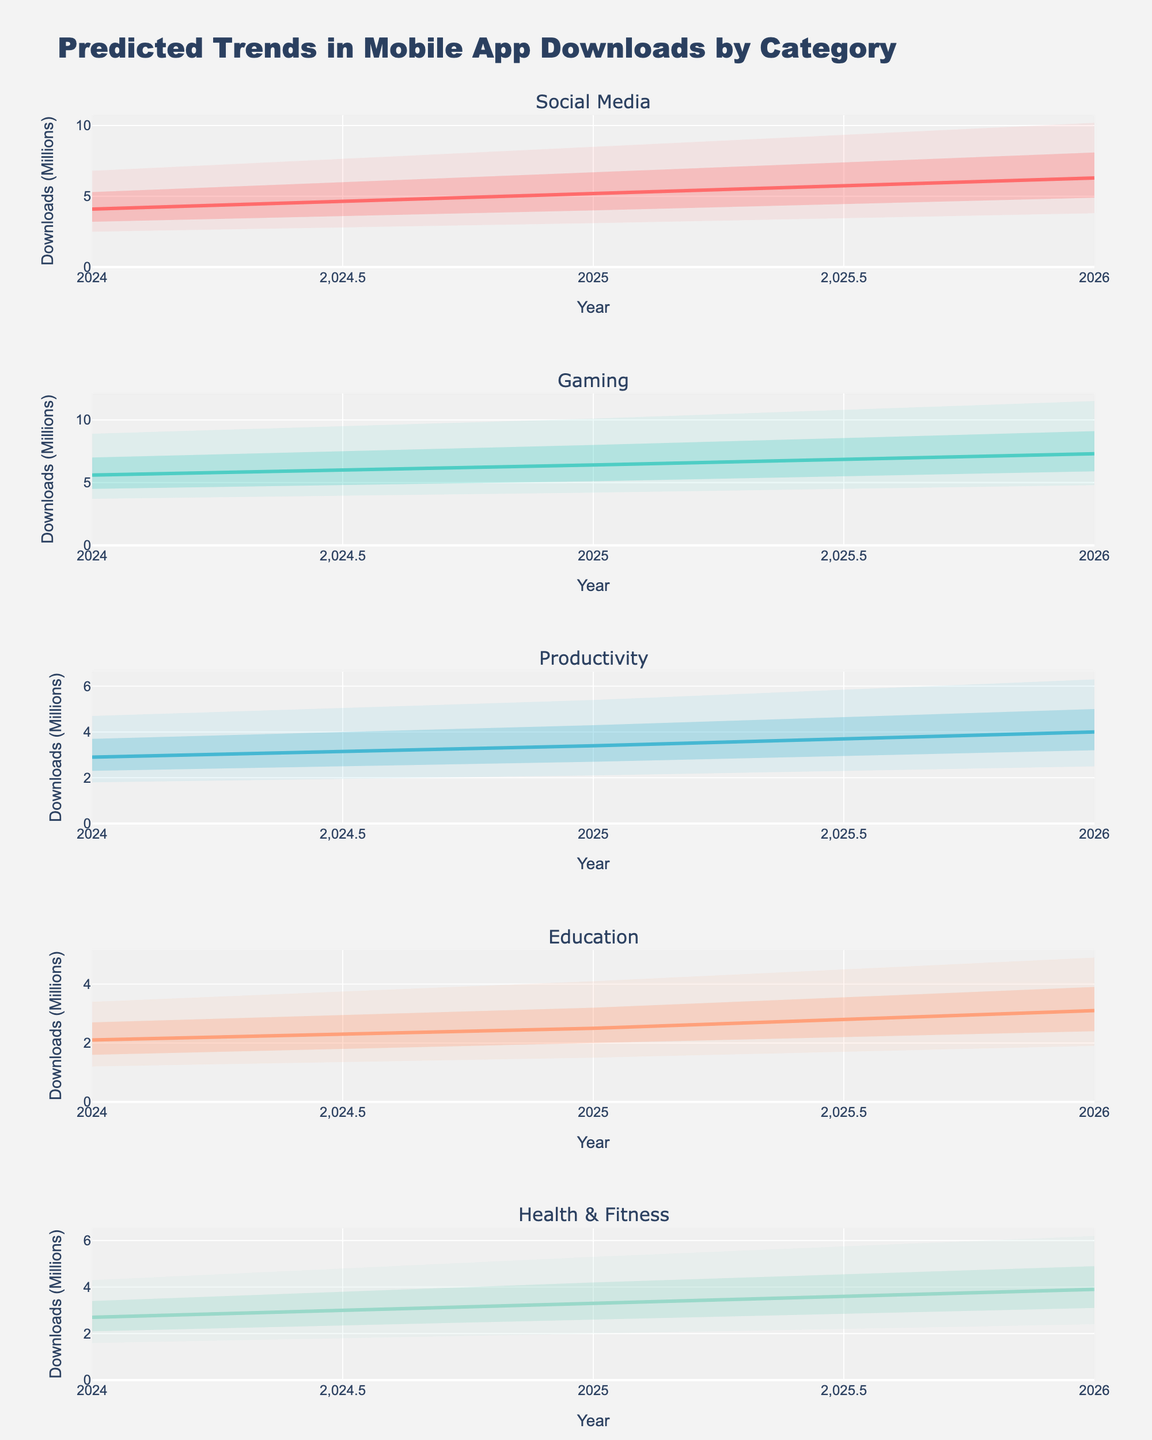What is the title of the figure? The title is located at the top of the figure and provides a summary of what the figure represents.
Answer: Predicted Trends in Mobile App Downloads by Category How many categories are represented in the figure? Each subplot title indicates a different category, and there are multiple subplots stacked vertically.
Answer: 5 What is the predicted median (P50) value for Social Media app downloads in 2025? Locate the Social Media category section, then look at the P50 line (typically the central line) for the year 2025.
Answer: 5.2 million Which category has the highest predicted P90 value in 2026? Compare the P90 predictions across categories for the year 2026, identifying the highest value.
Answer: Gaming What is the range between P10 and P90 values for Productivity apps in 2024? Subtract the P10 value from the P90 value within the Productivity category for the year 2024. The range = 4.7 - 1.8.
Answer: 2.9 million Which category shows the steepest increase in the median (P50) download prediction from 2024 to 2026? For each category, subtract the 2024 P50 value from the 2026 P50 value, and identify the category with the greatest increase. Social Media: 6.3 - 4.1 = 2.2, Gaming: 7.3 - 5.6 = 1.7, Productivity: 4.0 - 2.9 = 1.1, Education: 3.1 - 2.1 = 1.0, Health & Fitness: 3.9 - 2.7 = 1.2.
Answer: Social Media What is the P25 value for Health & Fitness app downloads in 2025? Look at the Health & Fitness category section, then locate the P25 line for the year 2025.
Answer: 2.6 million Which category has the widest prediction interval (difference between P10 and P90) in 2025? Calculate the difference between P10 and P90 for each category in 2025. Social Media: 8.5 - 3.1 = 5.4, Gaming: 10.1 - 4.2 = 5.9, Productivity: 5.4 - 2.1 = 3.3, Education: 4.1 - 1.5 = 2.6, Health & Fitness: 5.3 - 2.0 = 3.3.
Answer: Gaming What is the consistent trend observed across all categories from 2024 to 2026? Analyze the general direction of the central (P50) lines in each category from 2024 to 2026, noting any consistent patterns.
Answer: Increasing How much is the predicted median download increase for Social Media apps from 2024 to 2026? Look at Social Media category, find the P50 values for 2024 and 2026, then calculate the difference. Increase = 6.3 - 4.1.
Answer: 2.2 million 